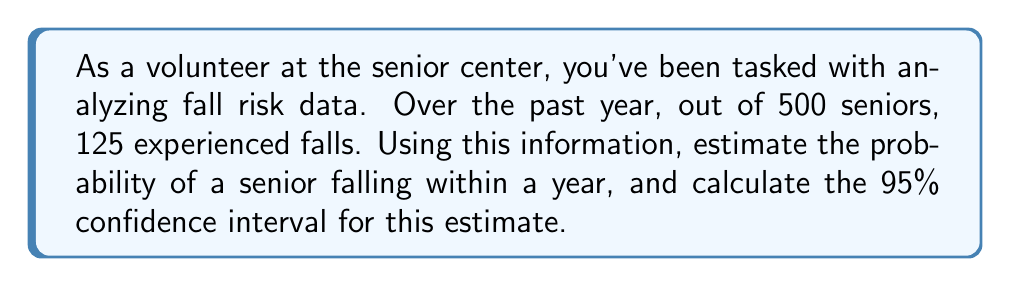Can you solve this math problem? 1. Calculate the point estimate:
   The probability estimate is the number of seniors who fell divided by the total number of seniors.
   $$p = \frac{125}{500} = 0.25$$

2. Calculate the standard error:
   $$SE = \sqrt{\frac{p(1-p)}{n}} = \sqrt{\frac{0.25(1-0.25)}{500}} = \sqrt{\frac{0.1875}{500}} \approx 0.0194$$

3. Find the critical value for a 95% confidence interval:
   For a 95% CI, use $z_{0.025} = 1.96$

4. Calculate the margin of error:
   $$ME = z_{0.025} \times SE = 1.96 \times 0.0194 \approx 0.038$$

5. Compute the confidence interval:
   $$CI = p \pm ME = 0.25 \pm 0.038$$
   Lower bound: $0.25 - 0.038 = 0.212$
   Upper bound: $0.25 + 0.038 = 0.288$

Therefore, we estimate that the probability of a senior falling within a year is 0.25 or 25%, with a 95% confidence interval of (0.212, 0.288) or (21.2%, 28.8%).
Answer: 0.25 (25%), 95% CI: (0.212, 0.288) 